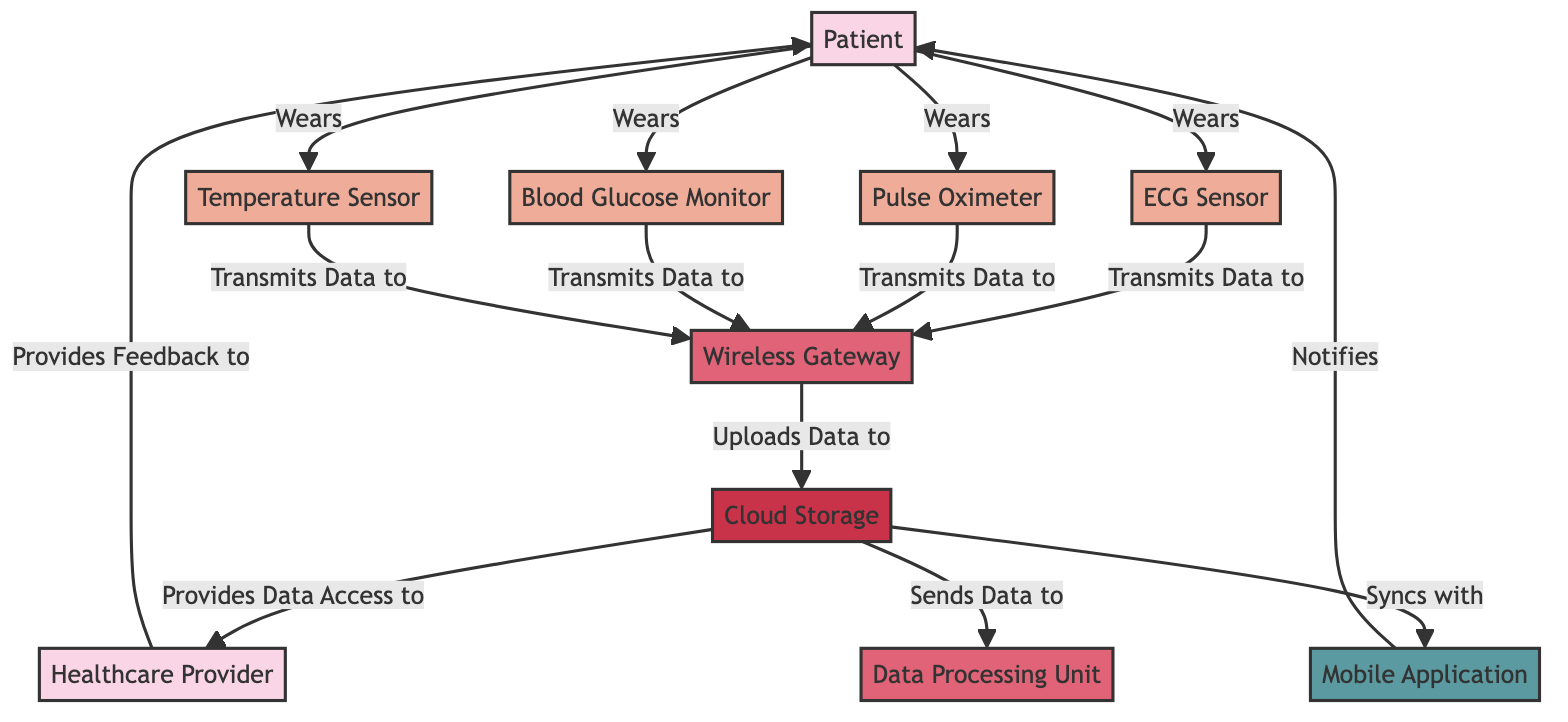What is the first wearable sensor listed? The diagram shows four wearable sensors that the patient wears, and the first one listed from top to bottom is the ECG Sensor.
Answer: ECG Sensor How many wearable sensors are represented in the diagram? The diagram features a total of four wearable sensors: ECG Sensor, Pulse Oximeter, Blood Glucose Monitor, and Temperature Sensor.
Answer: 4 Which device uploads data to cloud storage? The Wireless Gateway is the device depicted in the diagram as responsible for uploading data to Cloud Storage.
Answer: Wireless Gateway What type of application syncs with cloud storage? The Mobile Application is indicated in the diagram as the type of application that syncs with Cloud Storage.
Answer: Mobile Application Who provides feedback to the patient? According to the diagram, the Healthcare Provider is shown as the entity that provides feedback to the Patient.
Answer: Healthcare Provider What is the relationship between the Wireless Gateway and the Cloud Storage? The diagram illustrates that the Wireless Gateway uploads data to the Cloud Storage.
Answer: Uploads Data to Which component is responsible for notifying the patient? The Mobile Application is responsible for notifying the Patient, as depicted in the diagram.
Answer: Mobile Application Which wearable sensors transmit data to the Wireless Gateway? The diagram shows that the ECG Sensor, Pulse Oximeter, Blood Glucose Monitor, and Temperature Sensor all transmit data to the Wireless Gateway.
Answer: ECG Sensor, Pulse Oximeter, Blood Glucose Monitor, Temperature Sensor What role does the Data Processing Unit play in the diagram? The Data Processing Unit receives data from Cloud Storage, as indicated in the diagram, suggesting its role in processing the uploaded data.
Answer: Sends Data to What feedback mechanism is shown in the diagram? The diagram indicates that the Healthcare Provider provides feedback to the Patient as a mechanism of interaction in the system.
Answer: Provides Feedback to 